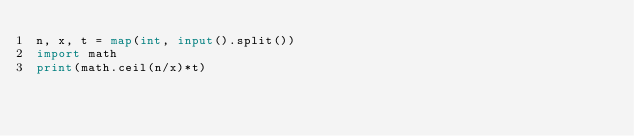<code> <loc_0><loc_0><loc_500><loc_500><_Python_>n, x, t = map(int, input().split())
import math
print(math.ceil(n/x)*t)</code> 